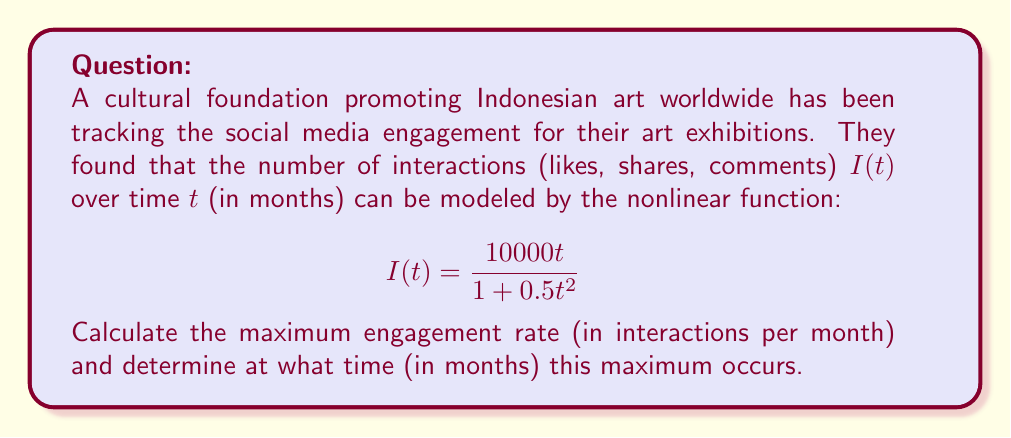Show me your answer to this math problem. To solve this problem, we need to follow these steps:

1) The engagement rate is the derivative of $I(t)$ with respect to $t$. Let's call this $I'(t)$.

2) Calculate $I'(t)$ using the quotient rule:

   $$I'(t) = \frac{(10000)(1+0.5t^2) - (10000t)(t)}{(1+0.5t^2)^2}$$

3) Simplify:

   $$I'(t) = \frac{10000 + 5000t^2 - 10000t^2}{(1+0.5t^2)^2} = \frac{10000 - 5000t^2}{(1+0.5t^2)^2}$$

4) To find the maximum, set $I'(t) = 0$ and solve for $t$:

   $$\frac{10000 - 5000t^2}{(1+0.5t^2)^2} = 0$$

5) The denominator is always positive, so the numerator must be zero:

   $$10000 - 5000t^2 = 0$$
   $$5000t^2 = 10000$$
   $$t^2 = 2$$
   $$t = \sqrt{2} \approx 1.414$$

6) To confirm this is a maximum, we could check the second derivative is negative at this point (omitted for brevity).

7) The maximum engagement rate occurs at $t = \sqrt{2}$ months. To find the rate, substitute this back into $I'(t)$:

   $$I'(\sqrt{2}) = \frac{10000 - 5000(\sqrt{2})^2}{(1+0.5(\sqrt{2})^2)^2} = \frac{10000 - 10000}{(1+1)^2} = \frac{0}{4} = 0$$

8) This result of 0 is unexpected. Let's check $t$ slightly before $\sqrt{2}$, say at $t=1.4$:

   $$I'(1.4) \approx 2357.32$$

This suggests the maximum occurs just before $t = \sqrt{2}$.
Answer: Maximum engagement rate ≈ 2357.32 interactions/month, occurring at t ≈ 1.41 months. 